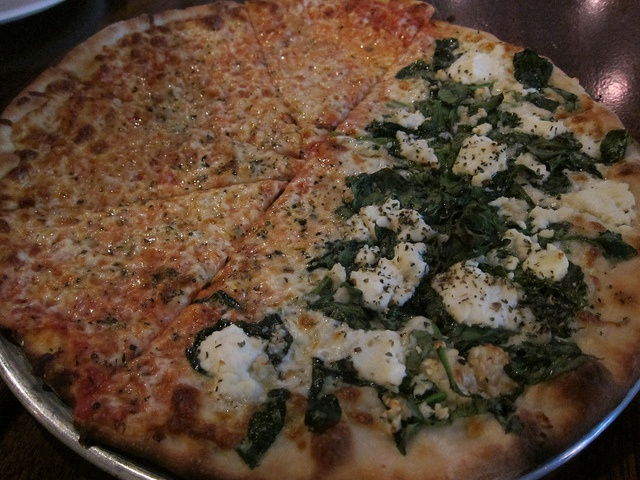Describe the objects in this image and their specific colors. I can see pizza in black, maroon, and gray tones and dining table in gray, black, and brown tones in this image. 